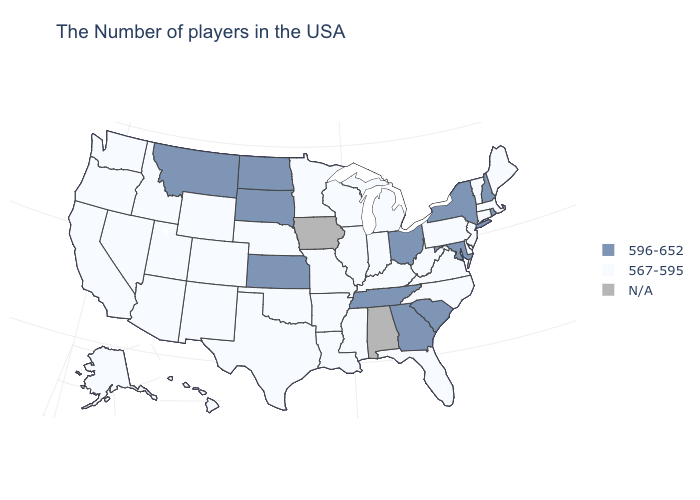What is the value of Alabama?
Short answer required. N/A. What is the value of Maine?
Give a very brief answer. 567-595. Does New Hampshire have the highest value in the Northeast?
Write a very short answer. Yes. What is the value of Maine?
Write a very short answer. 567-595. What is the highest value in the West ?
Keep it brief. 596-652. What is the value of Texas?
Answer briefly. 567-595. What is the lowest value in the USA?
Write a very short answer. 567-595. Name the states that have a value in the range N/A?
Be succinct. Alabama, Iowa. Is the legend a continuous bar?
Answer briefly. No. Name the states that have a value in the range 596-652?
Give a very brief answer. Rhode Island, New Hampshire, New York, Maryland, South Carolina, Ohio, Georgia, Tennessee, Kansas, South Dakota, North Dakota, Montana. What is the value of Connecticut?
Short answer required. 567-595. Name the states that have a value in the range N/A?
Answer briefly. Alabama, Iowa. Name the states that have a value in the range N/A?
Quick response, please. Alabama, Iowa. 